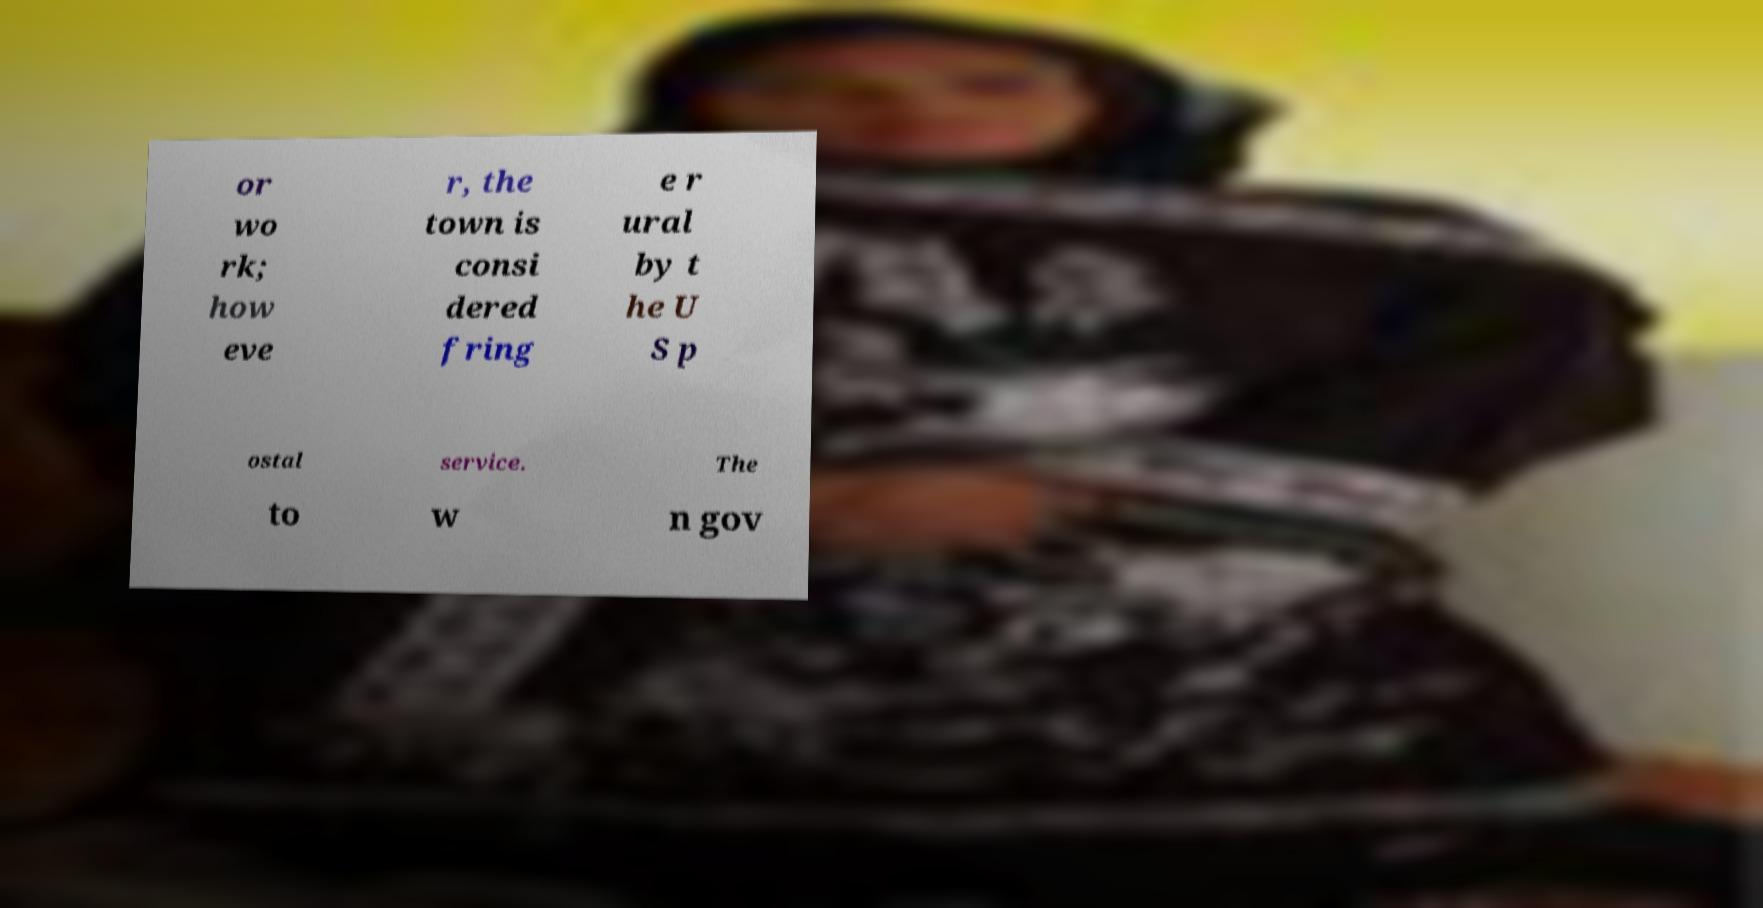Could you extract and type out the text from this image? or wo rk; how eve r, the town is consi dered fring e r ural by t he U S p ostal service. The to w n gov 